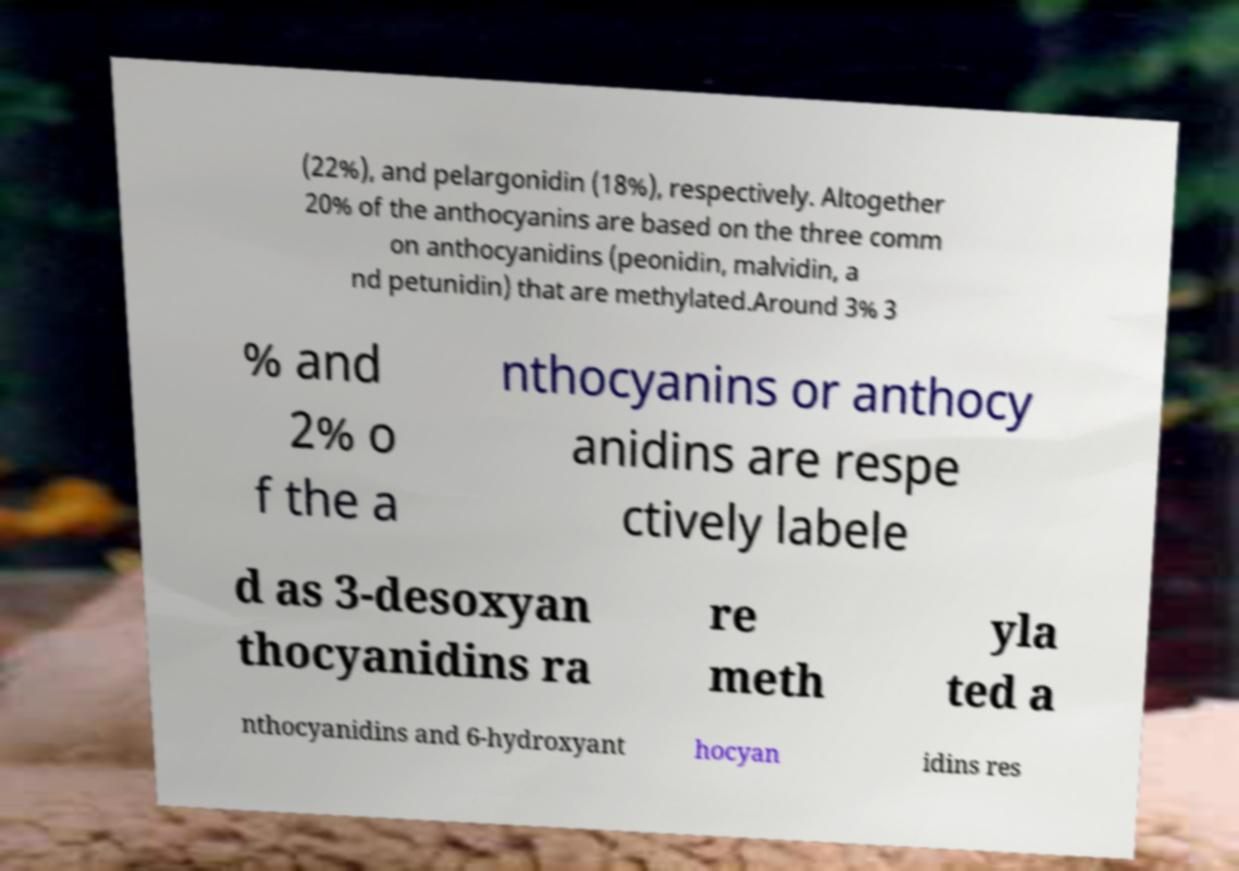Could you assist in decoding the text presented in this image and type it out clearly? (22%), and pelargonidin (18%), respectively. Altogether 20% of the anthocyanins are based on the three comm on anthocyanidins (peonidin, malvidin, a nd petunidin) that are methylated.Around 3% 3 % and 2% o f the a nthocyanins or anthocy anidins are respe ctively labele d as 3-desoxyan thocyanidins ra re meth yla ted a nthocyanidins and 6-hydroxyant hocyan idins res 